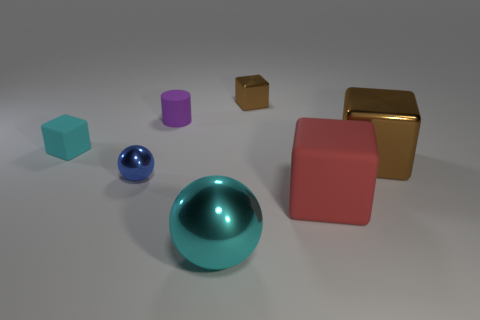Subtract 1 blocks. How many blocks are left? 3 Add 1 cylinders. How many objects exist? 8 Subtract all green cubes. Subtract all cyan spheres. How many cubes are left? 4 Subtract all spheres. How many objects are left? 5 Subtract 0 yellow cubes. How many objects are left? 7 Subtract all large shiny balls. Subtract all brown shiny objects. How many objects are left? 4 Add 4 tiny blue balls. How many tiny blue balls are left? 5 Add 5 large brown cylinders. How many large brown cylinders exist? 5 